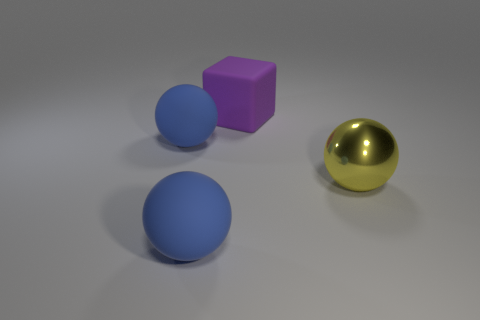Subtract all yellow metal balls. How many balls are left? 2 Subtract 3 balls. How many balls are left? 0 Add 1 large metallic spheres. How many objects exist? 5 Subtract all yellow spheres. How many spheres are left? 2 Subtract all spheres. How many objects are left? 1 Subtract 0 yellow cylinders. How many objects are left? 4 Subtract all cyan balls. Subtract all green blocks. How many balls are left? 3 Subtract all purple blocks. How many yellow spheres are left? 1 Subtract all blue matte balls. Subtract all purple cubes. How many objects are left? 1 Add 1 yellow balls. How many yellow balls are left? 2 